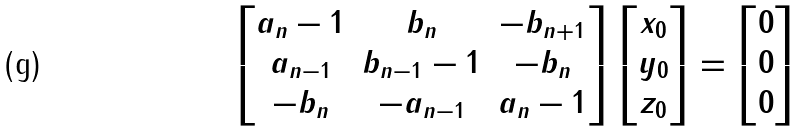<formula> <loc_0><loc_0><loc_500><loc_500>\left [ \begin{matrix} a _ { n } - 1 & b _ { n } & - b _ { n + 1 } \\ a _ { n - 1 } & b _ { n - 1 } - 1 & - b _ { n } \\ - b _ { n } & - a _ { n - 1 } & a _ { n } - 1 \end{matrix} \right ] \left [ \begin{matrix} x _ { 0 } \\ y _ { 0 } \\ z _ { 0 } \end{matrix} \right ] = \left [ \begin{matrix} 0 \\ 0 \\ 0 \end{matrix} \right ]</formula> 